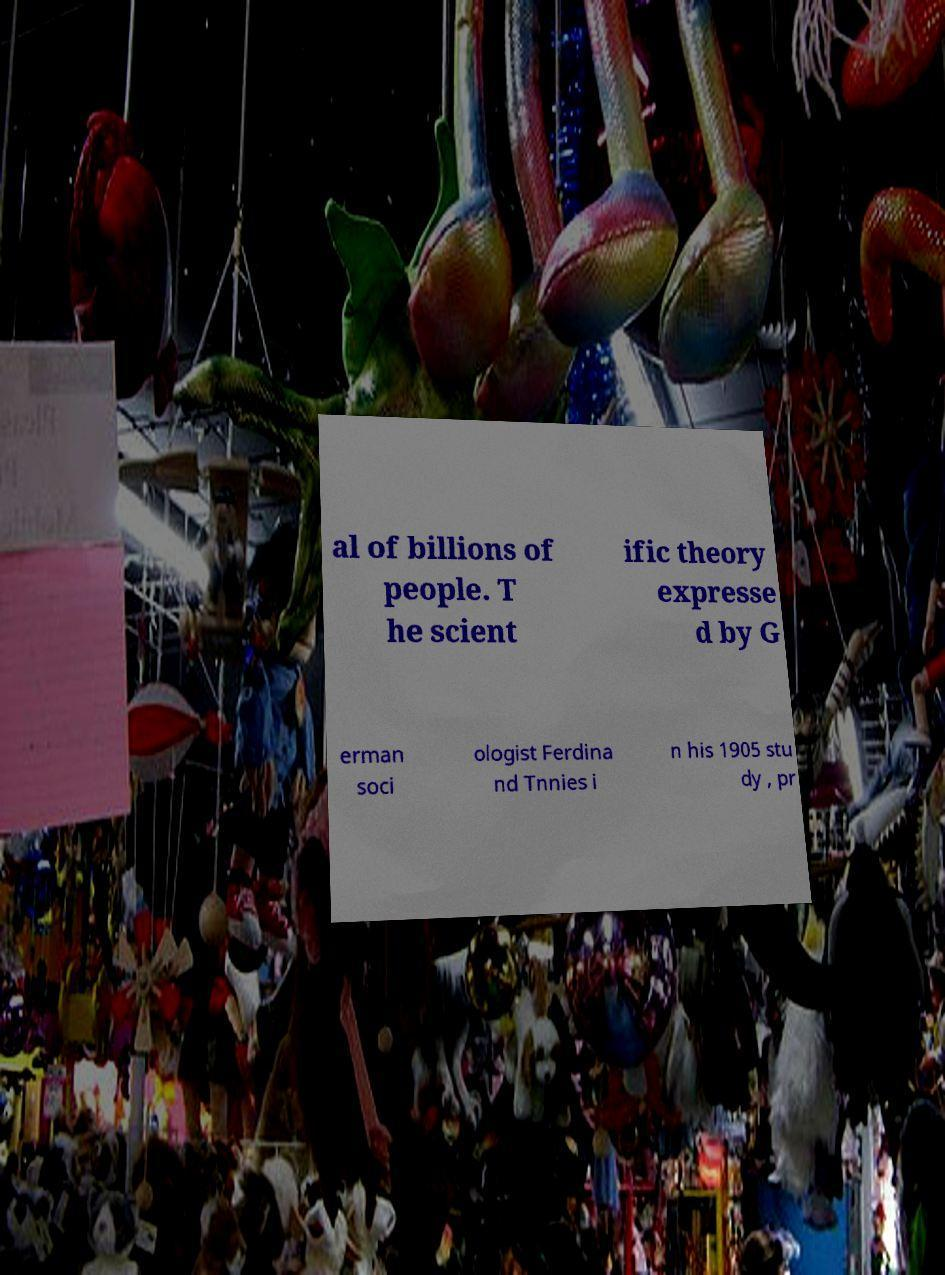What messages or text are displayed in this image? I need them in a readable, typed format. al of billions of people. T he scient ific theory expresse d by G erman soci ologist Ferdina nd Tnnies i n his 1905 stu dy , pr 